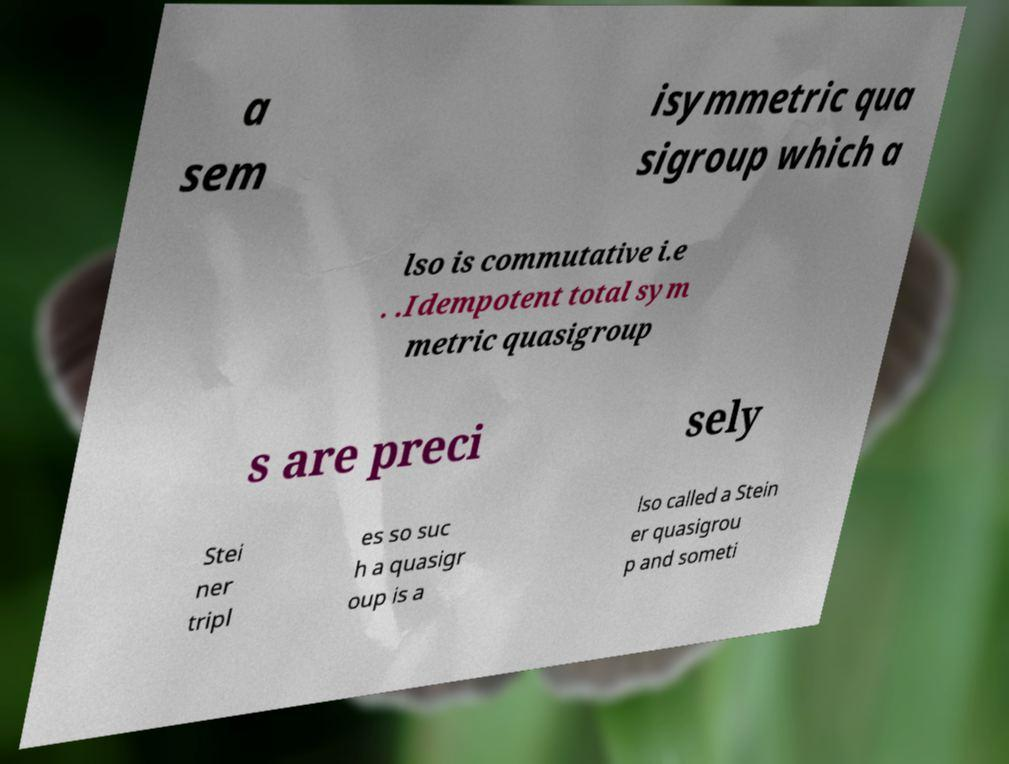Please identify and transcribe the text found in this image. a sem isymmetric qua sigroup which a lso is commutative i.e . .Idempotent total sym metric quasigroup s are preci sely Stei ner tripl es so suc h a quasigr oup is a lso called a Stein er quasigrou p and someti 